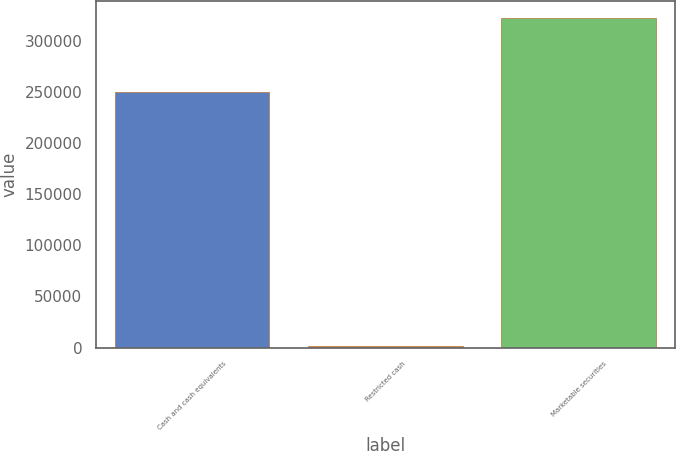Convert chart to OTSL. <chart><loc_0><loc_0><loc_500><loc_500><bar_chart><fcel>Cash and cash equivalents<fcel>Restricted cash<fcel>Marketable securities<nl><fcel>249909<fcel>1457<fcel>322215<nl></chart> 